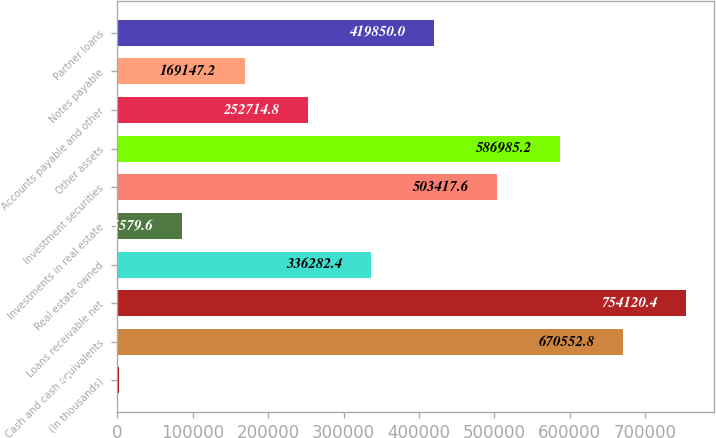Convert chart to OTSL. <chart><loc_0><loc_0><loc_500><loc_500><bar_chart><fcel>(In thousands)<fcel>Cash and cash equivalents<fcel>Loans receivable net<fcel>Real estate owned<fcel>Investments in real estate<fcel>Investment securities<fcel>Other assets<fcel>Accounts payable and other<fcel>Notes payable<fcel>Partner loans<nl><fcel>2012<fcel>670553<fcel>754120<fcel>336282<fcel>85579.6<fcel>503418<fcel>586985<fcel>252715<fcel>169147<fcel>419850<nl></chart> 